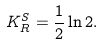Convert formula to latex. <formula><loc_0><loc_0><loc_500><loc_500>K _ { R } ^ { S } = \frac { 1 } { 2 } \ln 2 .</formula> 